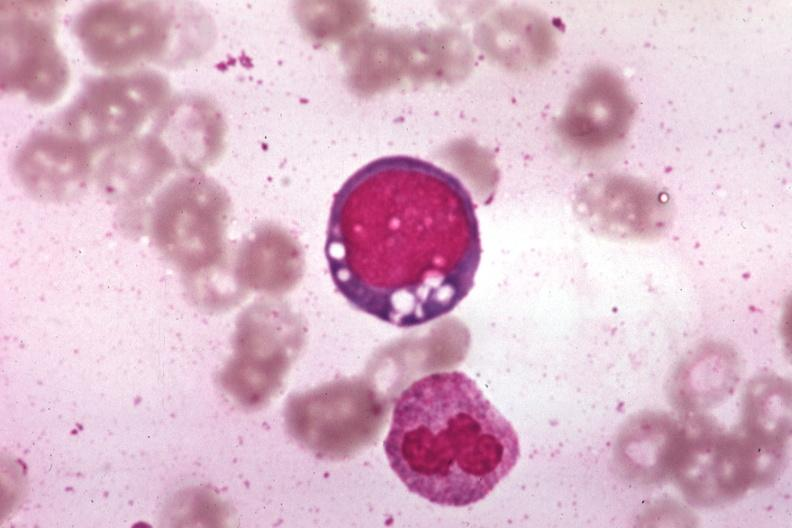what is present?
Answer the question using a single word or phrase. Chloramphenicol toxicity 